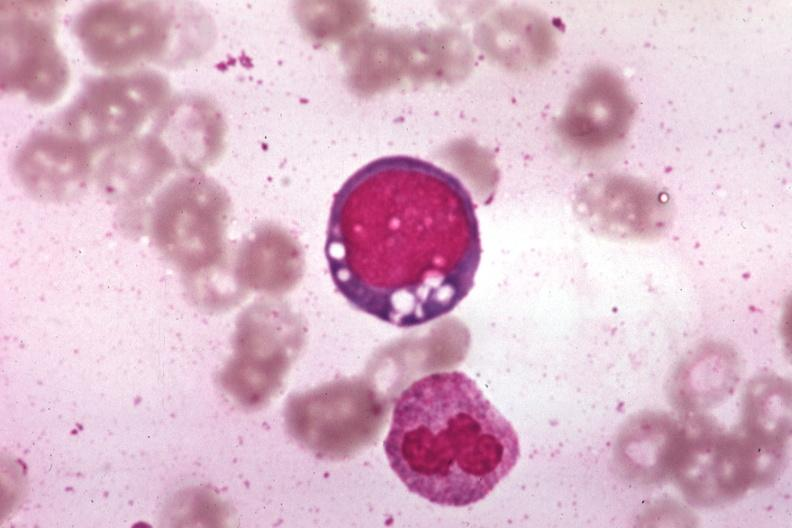what is present?
Answer the question using a single word or phrase. Chloramphenicol toxicity 